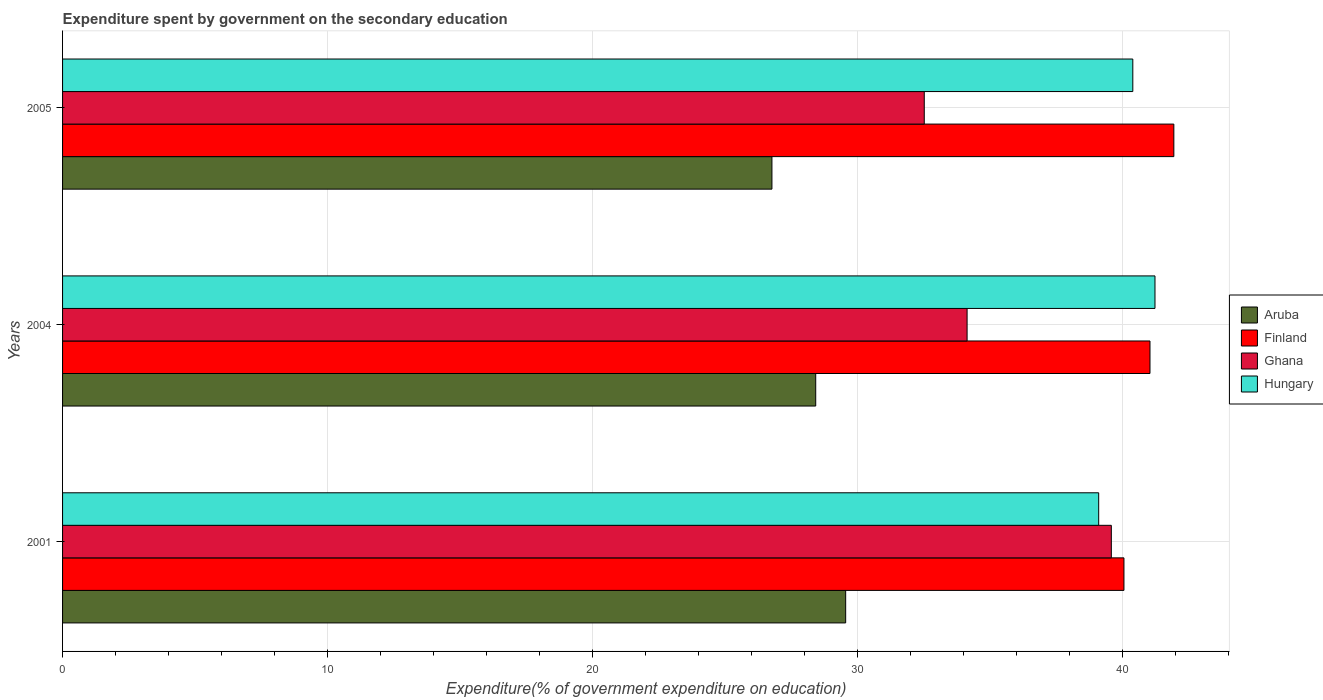How many different coloured bars are there?
Offer a terse response. 4. How many groups of bars are there?
Provide a succinct answer. 3. Are the number of bars per tick equal to the number of legend labels?
Ensure brevity in your answer.  Yes. Are the number of bars on each tick of the Y-axis equal?
Offer a terse response. Yes. How many bars are there on the 1st tick from the top?
Your response must be concise. 4. What is the expenditure spent by government on the secondary education in Aruba in 2004?
Make the answer very short. 28.42. Across all years, what is the maximum expenditure spent by government on the secondary education in Aruba?
Make the answer very short. 29.55. Across all years, what is the minimum expenditure spent by government on the secondary education in Finland?
Give a very brief answer. 40.05. What is the total expenditure spent by government on the secondary education in Aruba in the graph?
Offer a terse response. 84.74. What is the difference between the expenditure spent by government on the secondary education in Ghana in 2001 and that in 2004?
Your answer should be compact. 5.44. What is the difference between the expenditure spent by government on the secondary education in Aruba in 2004 and the expenditure spent by government on the secondary education in Hungary in 2001?
Provide a short and direct response. -10.68. What is the average expenditure spent by government on the secondary education in Finland per year?
Offer a very short reply. 41.01. In the year 2005, what is the difference between the expenditure spent by government on the secondary education in Hungary and expenditure spent by government on the secondary education in Aruba?
Offer a terse response. 13.62. In how many years, is the expenditure spent by government on the secondary education in Ghana greater than 8 %?
Keep it short and to the point. 3. What is the ratio of the expenditure spent by government on the secondary education in Finland in 2004 to that in 2005?
Offer a very short reply. 0.98. Is the difference between the expenditure spent by government on the secondary education in Hungary in 2001 and 2005 greater than the difference between the expenditure spent by government on the secondary education in Aruba in 2001 and 2005?
Keep it short and to the point. No. What is the difference between the highest and the second highest expenditure spent by government on the secondary education in Ghana?
Keep it short and to the point. 5.44. What is the difference between the highest and the lowest expenditure spent by government on the secondary education in Hungary?
Offer a very short reply. 2.12. Is it the case that in every year, the sum of the expenditure spent by government on the secondary education in Aruba and expenditure spent by government on the secondary education in Ghana is greater than the sum of expenditure spent by government on the secondary education in Finland and expenditure spent by government on the secondary education in Hungary?
Make the answer very short. Yes. What does the 1st bar from the bottom in 2004 represents?
Your answer should be compact. Aruba. Is it the case that in every year, the sum of the expenditure spent by government on the secondary education in Hungary and expenditure spent by government on the secondary education in Aruba is greater than the expenditure spent by government on the secondary education in Ghana?
Your response must be concise. Yes. Are all the bars in the graph horizontal?
Your answer should be compact. Yes. How many legend labels are there?
Offer a terse response. 4. What is the title of the graph?
Offer a very short reply. Expenditure spent by government on the secondary education. Does "Turkmenistan" appear as one of the legend labels in the graph?
Offer a terse response. No. What is the label or title of the X-axis?
Ensure brevity in your answer.  Expenditure(% of government expenditure on education). What is the Expenditure(% of government expenditure on education) in Aruba in 2001?
Offer a very short reply. 29.55. What is the Expenditure(% of government expenditure on education) of Finland in 2001?
Ensure brevity in your answer.  40.05. What is the Expenditure(% of government expenditure on education) in Ghana in 2001?
Offer a terse response. 39.58. What is the Expenditure(% of government expenditure on education) of Hungary in 2001?
Give a very brief answer. 39.1. What is the Expenditure(% of government expenditure on education) in Aruba in 2004?
Offer a terse response. 28.42. What is the Expenditure(% of government expenditure on education) in Finland in 2004?
Your answer should be very brief. 41.03. What is the Expenditure(% of government expenditure on education) of Ghana in 2004?
Your answer should be very brief. 34.13. What is the Expenditure(% of government expenditure on education) of Hungary in 2004?
Offer a terse response. 41.22. What is the Expenditure(% of government expenditure on education) of Aruba in 2005?
Your answer should be compact. 26.77. What is the Expenditure(% of government expenditure on education) in Finland in 2005?
Give a very brief answer. 41.93. What is the Expenditure(% of government expenditure on education) in Ghana in 2005?
Make the answer very short. 32.52. What is the Expenditure(% of government expenditure on education) of Hungary in 2005?
Provide a succinct answer. 40.39. Across all years, what is the maximum Expenditure(% of government expenditure on education) of Aruba?
Offer a very short reply. 29.55. Across all years, what is the maximum Expenditure(% of government expenditure on education) of Finland?
Offer a terse response. 41.93. Across all years, what is the maximum Expenditure(% of government expenditure on education) in Ghana?
Make the answer very short. 39.58. Across all years, what is the maximum Expenditure(% of government expenditure on education) of Hungary?
Give a very brief answer. 41.22. Across all years, what is the minimum Expenditure(% of government expenditure on education) of Aruba?
Keep it short and to the point. 26.77. Across all years, what is the minimum Expenditure(% of government expenditure on education) of Finland?
Keep it short and to the point. 40.05. Across all years, what is the minimum Expenditure(% of government expenditure on education) in Ghana?
Your answer should be compact. 32.52. Across all years, what is the minimum Expenditure(% of government expenditure on education) of Hungary?
Provide a succinct answer. 39.1. What is the total Expenditure(% of government expenditure on education) in Aruba in the graph?
Provide a short and direct response. 84.74. What is the total Expenditure(% of government expenditure on education) of Finland in the graph?
Keep it short and to the point. 123.02. What is the total Expenditure(% of government expenditure on education) of Ghana in the graph?
Offer a terse response. 106.22. What is the total Expenditure(% of government expenditure on education) in Hungary in the graph?
Your response must be concise. 120.71. What is the difference between the Expenditure(% of government expenditure on education) of Aruba in 2001 and that in 2004?
Give a very brief answer. 1.13. What is the difference between the Expenditure(% of government expenditure on education) in Finland in 2001 and that in 2004?
Offer a very short reply. -0.98. What is the difference between the Expenditure(% of government expenditure on education) in Ghana in 2001 and that in 2004?
Your answer should be very brief. 5.44. What is the difference between the Expenditure(% of government expenditure on education) of Hungary in 2001 and that in 2004?
Offer a very short reply. -2.12. What is the difference between the Expenditure(% of government expenditure on education) in Aruba in 2001 and that in 2005?
Give a very brief answer. 2.78. What is the difference between the Expenditure(% of government expenditure on education) of Finland in 2001 and that in 2005?
Offer a very short reply. -1.88. What is the difference between the Expenditure(% of government expenditure on education) of Ghana in 2001 and that in 2005?
Offer a very short reply. 7.06. What is the difference between the Expenditure(% of government expenditure on education) in Hungary in 2001 and that in 2005?
Make the answer very short. -1.29. What is the difference between the Expenditure(% of government expenditure on education) of Aruba in 2004 and that in 2005?
Offer a terse response. 1.65. What is the difference between the Expenditure(% of government expenditure on education) in Finland in 2004 and that in 2005?
Make the answer very short. -0.9. What is the difference between the Expenditure(% of government expenditure on education) of Ghana in 2004 and that in 2005?
Provide a short and direct response. 1.62. What is the difference between the Expenditure(% of government expenditure on education) of Hungary in 2004 and that in 2005?
Provide a short and direct response. 0.84. What is the difference between the Expenditure(% of government expenditure on education) of Aruba in 2001 and the Expenditure(% of government expenditure on education) of Finland in 2004?
Your answer should be very brief. -11.48. What is the difference between the Expenditure(% of government expenditure on education) of Aruba in 2001 and the Expenditure(% of government expenditure on education) of Ghana in 2004?
Keep it short and to the point. -4.58. What is the difference between the Expenditure(% of government expenditure on education) in Aruba in 2001 and the Expenditure(% of government expenditure on education) in Hungary in 2004?
Keep it short and to the point. -11.67. What is the difference between the Expenditure(% of government expenditure on education) in Finland in 2001 and the Expenditure(% of government expenditure on education) in Ghana in 2004?
Make the answer very short. 5.92. What is the difference between the Expenditure(% of government expenditure on education) of Finland in 2001 and the Expenditure(% of government expenditure on education) of Hungary in 2004?
Your answer should be compact. -1.17. What is the difference between the Expenditure(% of government expenditure on education) of Ghana in 2001 and the Expenditure(% of government expenditure on education) of Hungary in 2004?
Offer a very short reply. -1.65. What is the difference between the Expenditure(% of government expenditure on education) in Aruba in 2001 and the Expenditure(% of government expenditure on education) in Finland in 2005?
Your response must be concise. -12.38. What is the difference between the Expenditure(% of government expenditure on education) in Aruba in 2001 and the Expenditure(% of government expenditure on education) in Ghana in 2005?
Give a very brief answer. -2.97. What is the difference between the Expenditure(% of government expenditure on education) in Aruba in 2001 and the Expenditure(% of government expenditure on education) in Hungary in 2005?
Provide a short and direct response. -10.83. What is the difference between the Expenditure(% of government expenditure on education) in Finland in 2001 and the Expenditure(% of government expenditure on education) in Ghana in 2005?
Give a very brief answer. 7.54. What is the difference between the Expenditure(% of government expenditure on education) of Finland in 2001 and the Expenditure(% of government expenditure on education) of Hungary in 2005?
Give a very brief answer. -0.33. What is the difference between the Expenditure(% of government expenditure on education) of Ghana in 2001 and the Expenditure(% of government expenditure on education) of Hungary in 2005?
Your response must be concise. -0.81. What is the difference between the Expenditure(% of government expenditure on education) of Aruba in 2004 and the Expenditure(% of government expenditure on education) of Finland in 2005?
Offer a very short reply. -13.51. What is the difference between the Expenditure(% of government expenditure on education) in Aruba in 2004 and the Expenditure(% of government expenditure on education) in Ghana in 2005?
Provide a succinct answer. -4.1. What is the difference between the Expenditure(% of government expenditure on education) of Aruba in 2004 and the Expenditure(% of government expenditure on education) of Hungary in 2005?
Ensure brevity in your answer.  -11.97. What is the difference between the Expenditure(% of government expenditure on education) in Finland in 2004 and the Expenditure(% of government expenditure on education) in Ghana in 2005?
Give a very brief answer. 8.52. What is the difference between the Expenditure(% of government expenditure on education) of Finland in 2004 and the Expenditure(% of government expenditure on education) of Hungary in 2005?
Give a very brief answer. 0.65. What is the difference between the Expenditure(% of government expenditure on education) of Ghana in 2004 and the Expenditure(% of government expenditure on education) of Hungary in 2005?
Provide a short and direct response. -6.25. What is the average Expenditure(% of government expenditure on education) of Aruba per year?
Your answer should be very brief. 28.25. What is the average Expenditure(% of government expenditure on education) of Finland per year?
Your answer should be very brief. 41.01. What is the average Expenditure(% of government expenditure on education) of Ghana per year?
Your answer should be compact. 35.41. What is the average Expenditure(% of government expenditure on education) of Hungary per year?
Offer a terse response. 40.24. In the year 2001, what is the difference between the Expenditure(% of government expenditure on education) of Aruba and Expenditure(% of government expenditure on education) of Finland?
Your response must be concise. -10.5. In the year 2001, what is the difference between the Expenditure(% of government expenditure on education) in Aruba and Expenditure(% of government expenditure on education) in Ghana?
Keep it short and to the point. -10.02. In the year 2001, what is the difference between the Expenditure(% of government expenditure on education) of Aruba and Expenditure(% of government expenditure on education) of Hungary?
Offer a very short reply. -9.55. In the year 2001, what is the difference between the Expenditure(% of government expenditure on education) of Finland and Expenditure(% of government expenditure on education) of Ghana?
Provide a succinct answer. 0.48. In the year 2001, what is the difference between the Expenditure(% of government expenditure on education) of Finland and Expenditure(% of government expenditure on education) of Hungary?
Give a very brief answer. 0.95. In the year 2001, what is the difference between the Expenditure(% of government expenditure on education) of Ghana and Expenditure(% of government expenditure on education) of Hungary?
Provide a succinct answer. 0.48. In the year 2004, what is the difference between the Expenditure(% of government expenditure on education) of Aruba and Expenditure(% of government expenditure on education) of Finland?
Give a very brief answer. -12.61. In the year 2004, what is the difference between the Expenditure(% of government expenditure on education) of Aruba and Expenditure(% of government expenditure on education) of Ghana?
Your response must be concise. -5.71. In the year 2004, what is the difference between the Expenditure(% of government expenditure on education) in Aruba and Expenditure(% of government expenditure on education) in Hungary?
Ensure brevity in your answer.  -12.8. In the year 2004, what is the difference between the Expenditure(% of government expenditure on education) in Finland and Expenditure(% of government expenditure on education) in Ghana?
Offer a terse response. 6.9. In the year 2004, what is the difference between the Expenditure(% of government expenditure on education) of Finland and Expenditure(% of government expenditure on education) of Hungary?
Offer a very short reply. -0.19. In the year 2004, what is the difference between the Expenditure(% of government expenditure on education) of Ghana and Expenditure(% of government expenditure on education) of Hungary?
Provide a short and direct response. -7.09. In the year 2005, what is the difference between the Expenditure(% of government expenditure on education) in Aruba and Expenditure(% of government expenditure on education) in Finland?
Make the answer very short. -15.17. In the year 2005, what is the difference between the Expenditure(% of government expenditure on education) of Aruba and Expenditure(% of government expenditure on education) of Ghana?
Your answer should be compact. -5.75. In the year 2005, what is the difference between the Expenditure(% of government expenditure on education) in Aruba and Expenditure(% of government expenditure on education) in Hungary?
Your answer should be compact. -13.62. In the year 2005, what is the difference between the Expenditure(% of government expenditure on education) in Finland and Expenditure(% of government expenditure on education) in Ghana?
Offer a terse response. 9.42. In the year 2005, what is the difference between the Expenditure(% of government expenditure on education) in Finland and Expenditure(% of government expenditure on education) in Hungary?
Offer a very short reply. 1.55. In the year 2005, what is the difference between the Expenditure(% of government expenditure on education) in Ghana and Expenditure(% of government expenditure on education) in Hungary?
Your answer should be compact. -7.87. What is the ratio of the Expenditure(% of government expenditure on education) of Aruba in 2001 to that in 2004?
Ensure brevity in your answer.  1.04. What is the ratio of the Expenditure(% of government expenditure on education) in Finland in 2001 to that in 2004?
Your answer should be very brief. 0.98. What is the ratio of the Expenditure(% of government expenditure on education) of Ghana in 2001 to that in 2004?
Offer a very short reply. 1.16. What is the ratio of the Expenditure(% of government expenditure on education) of Hungary in 2001 to that in 2004?
Provide a short and direct response. 0.95. What is the ratio of the Expenditure(% of government expenditure on education) of Aruba in 2001 to that in 2005?
Offer a terse response. 1.1. What is the ratio of the Expenditure(% of government expenditure on education) of Finland in 2001 to that in 2005?
Offer a terse response. 0.96. What is the ratio of the Expenditure(% of government expenditure on education) in Ghana in 2001 to that in 2005?
Keep it short and to the point. 1.22. What is the ratio of the Expenditure(% of government expenditure on education) in Hungary in 2001 to that in 2005?
Provide a short and direct response. 0.97. What is the ratio of the Expenditure(% of government expenditure on education) of Aruba in 2004 to that in 2005?
Offer a very short reply. 1.06. What is the ratio of the Expenditure(% of government expenditure on education) in Finland in 2004 to that in 2005?
Ensure brevity in your answer.  0.98. What is the ratio of the Expenditure(% of government expenditure on education) in Ghana in 2004 to that in 2005?
Make the answer very short. 1.05. What is the ratio of the Expenditure(% of government expenditure on education) in Hungary in 2004 to that in 2005?
Provide a succinct answer. 1.02. What is the difference between the highest and the second highest Expenditure(% of government expenditure on education) of Aruba?
Provide a succinct answer. 1.13. What is the difference between the highest and the second highest Expenditure(% of government expenditure on education) in Finland?
Keep it short and to the point. 0.9. What is the difference between the highest and the second highest Expenditure(% of government expenditure on education) in Ghana?
Offer a terse response. 5.44. What is the difference between the highest and the second highest Expenditure(% of government expenditure on education) in Hungary?
Offer a terse response. 0.84. What is the difference between the highest and the lowest Expenditure(% of government expenditure on education) in Aruba?
Give a very brief answer. 2.78. What is the difference between the highest and the lowest Expenditure(% of government expenditure on education) of Finland?
Your response must be concise. 1.88. What is the difference between the highest and the lowest Expenditure(% of government expenditure on education) of Ghana?
Make the answer very short. 7.06. What is the difference between the highest and the lowest Expenditure(% of government expenditure on education) of Hungary?
Provide a short and direct response. 2.12. 